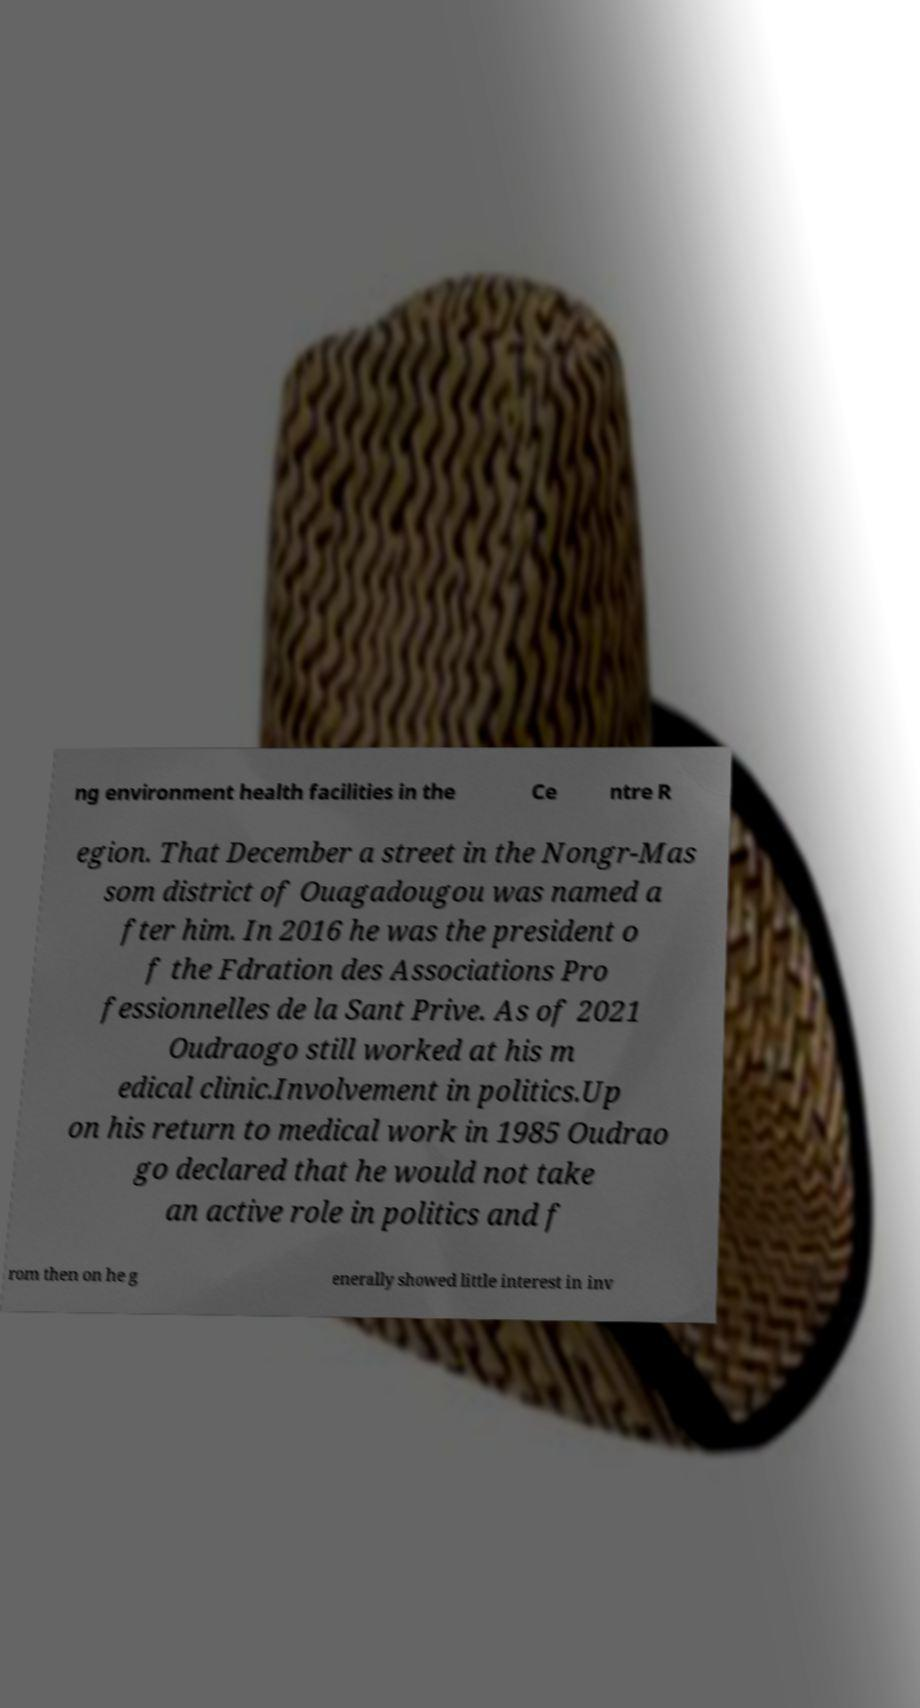Could you assist in decoding the text presented in this image and type it out clearly? ng environment health facilities in the Ce ntre R egion. That December a street in the Nongr-Mas som district of Ouagadougou was named a fter him. In 2016 he was the president o f the Fdration des Associations Pro fessionnelles de la Sant Prive. As of 2021 Oudraogo still worked at his m edical clinic.Involvement in politics.Up on his return to medical work in 1985 Oudrao go declared that he would not take an active role in politics and f rom then on he g enerally showed little interest in inv 